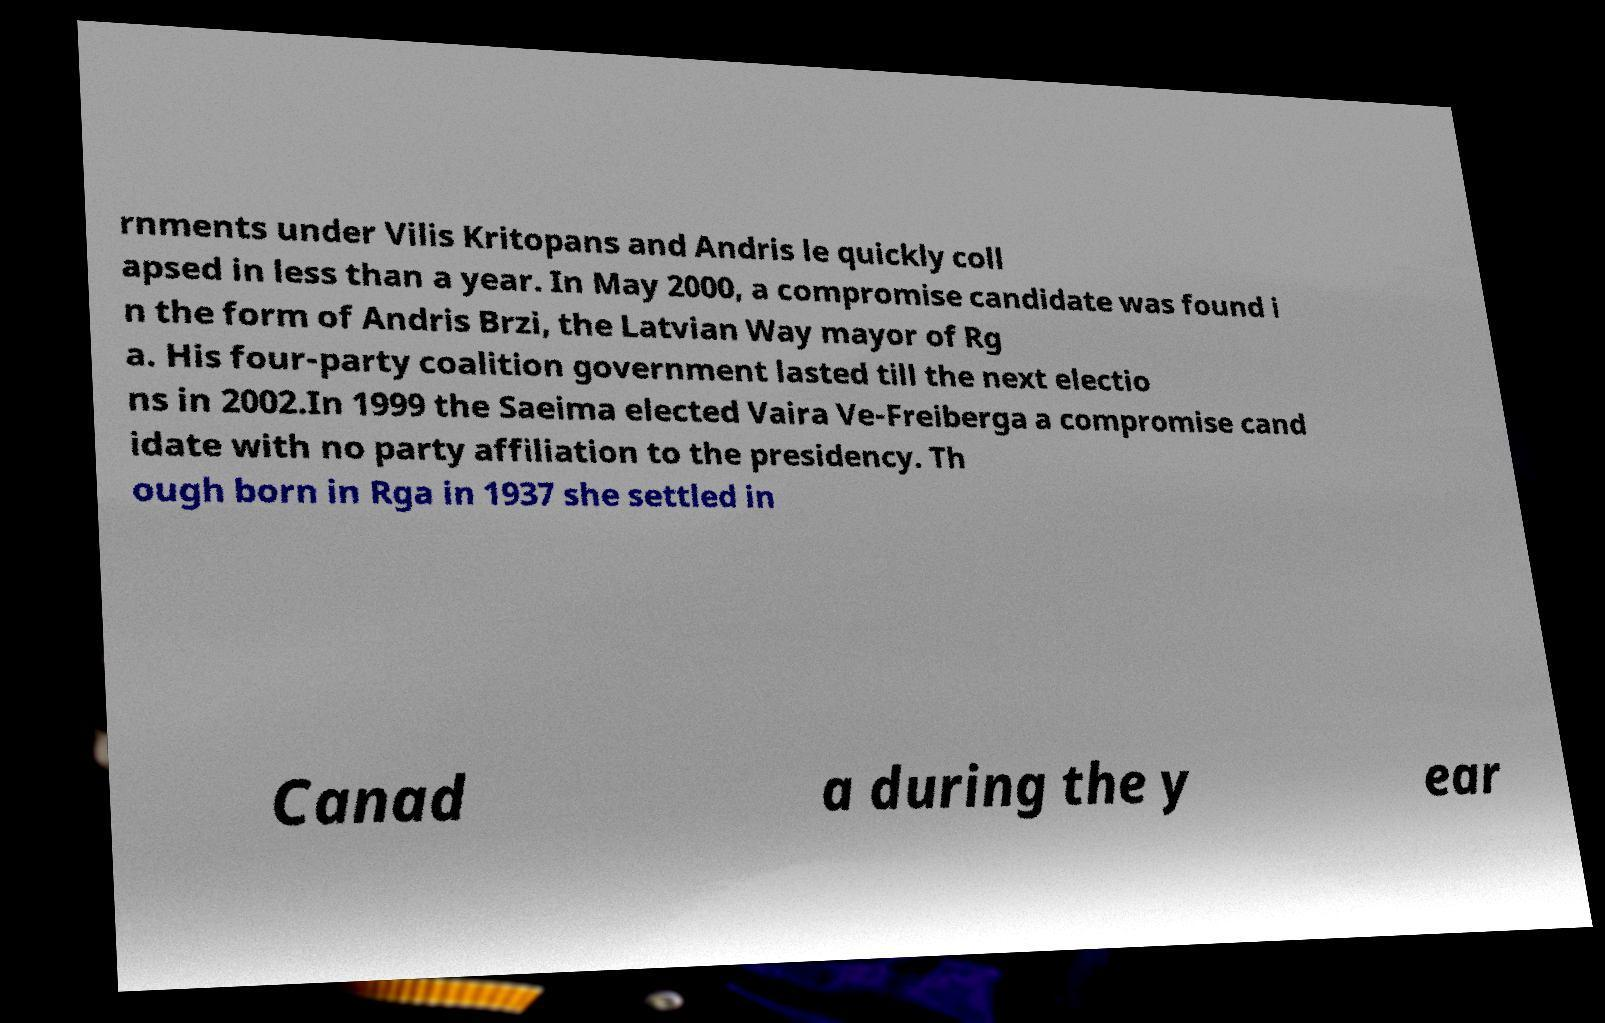For documentation purposes, I need the text within this image transcribed. Could you provide that? rnments under Vilis Kritopans and Andris le quickly coll apsed in less than a year. In May 2000, a compromise candidate was found i n the form of Andris Brzi, the Latvian Way mayor of Rg a. His four-party coalition government lasted till the next electio ns in 2002.In 1999 the Saeima elected Vaira Ve-Freiberga a compromise cand idate with no party affiliation to the presidency. Th ough born in Rga in 1937 she settled in Canad a during the y ear 